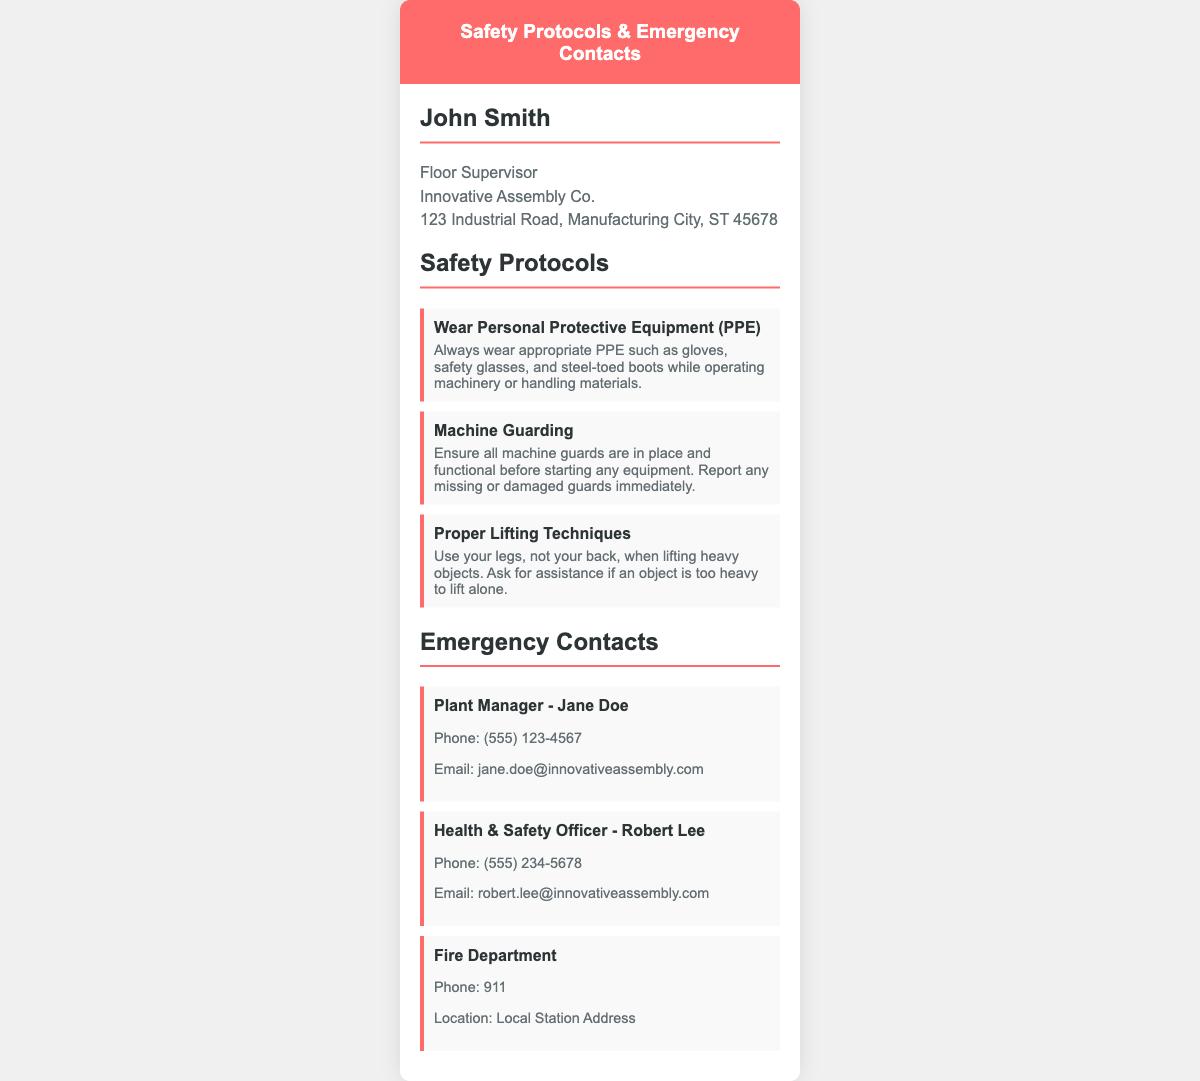What is the title of the floor supervisor? The title mentioned for the floor supervisor in the document is "Floor Supervisor".
Answer: Floor Supervisor Who is the Health & Safety Officer? The document identifies Robert Lee as the Health & Safety Officer.
Answer: Robert Lee What phone number do you call for emergencies? The document states that the emergency phone number is 911.
Answer: 911 What personal protective equipment is mentioned? The safety protocol mentions wearing gloves, safety glasses, and steel-toed boots.
Answer: Gloves, safety glasses, steel-toed boots What is the email address for the Plant Manager? The document provides the email address for the Plant Manager as jane.doe@innovativeassembly.com.
Answer: jane.doe@innovativeassembly.com Which safety protocol involves lifting techniques? The protocol that discusses lifting techniques is titled "Proper Lifting Techniques".
Answer: Proper Lifting Techniques What should you do if a machine guard is missing? The protocol specifies to report any missing or damaged guards immediately.
Answer: Report immediately What location is listed for the Fire Department? The document specifies "Local Station Address" for the Fire Department location.
Answer: Local Station Address How many safety protocols are listed in the document? There are three safety protocols detailed within the document.
Answer: Three 